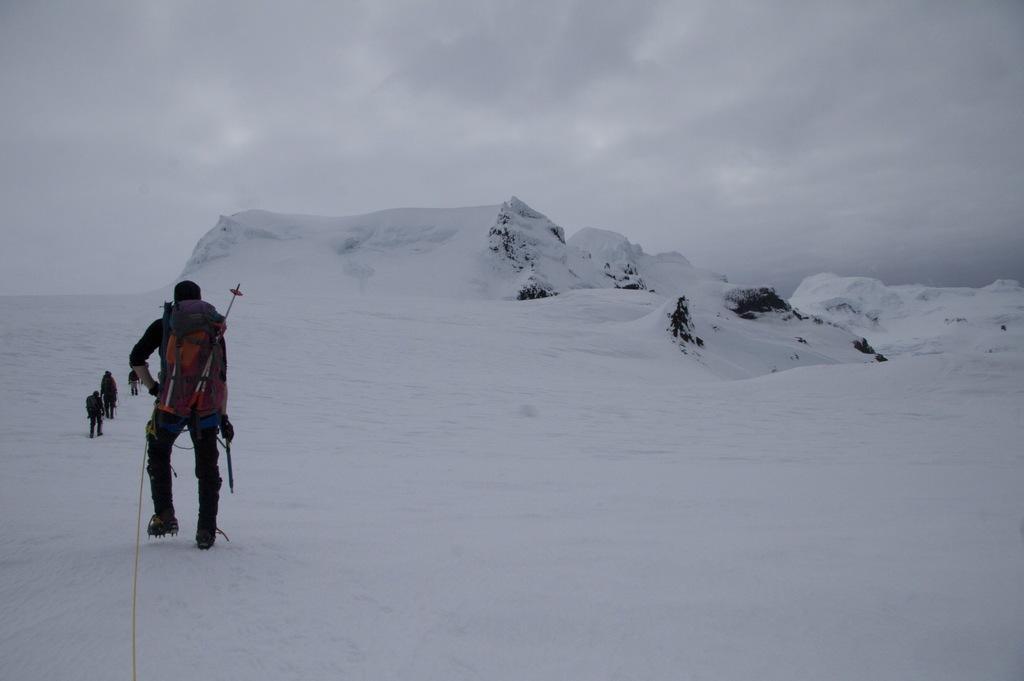Could you give a brief overview of what you see in this image? In this picture we can see group of people, they are walking on the snow, in the background we can see clouds. 